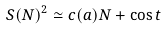<formula> <loc_0><loc_0><loc_500><loc_500>S ( N ) ^ { 2 } \simeq c ( a ) N + \cos t</formula> 